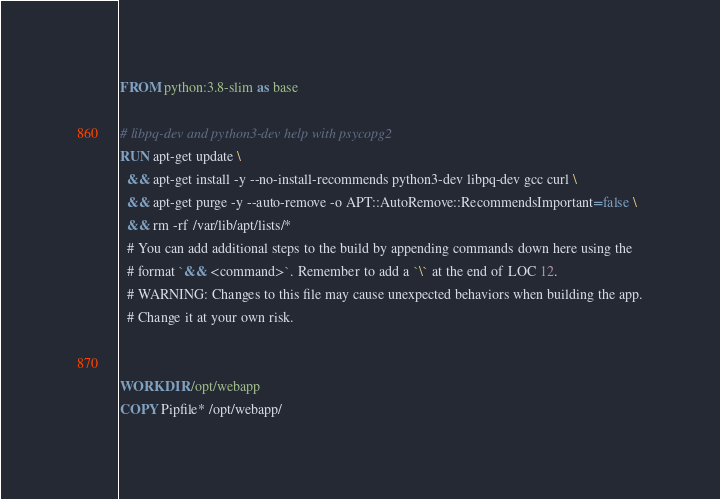Convert code to text. <code><loc_0><loc_0><loc_500><loc_500><_Dockerfile_>FROM python:3.8-slim as base

# libpq-dev and python3-dev help with psycopg2
RUN apt-get update \
  && apt-get install -y --no-install-recommends python3-dev libpq-dev gcc curl \
  && apt-get purge -y --auto-remove -o APT::AutoRemove::RecommendsImportant=false \
  && rm -rf /var/lib/apt/lists/*
  # You can add additional steps to the build by appending commands down here using the
  # format `&& <command>`. Remember to add a `\` at the end of LOC 12.
  # WARNING: Changes to this file may cause unexpected behaviors when building the app.
  # Change it at your own risk.


WORKDIR /opt/webapp
COPY Pipfile* /opt/webapp/
</code> 